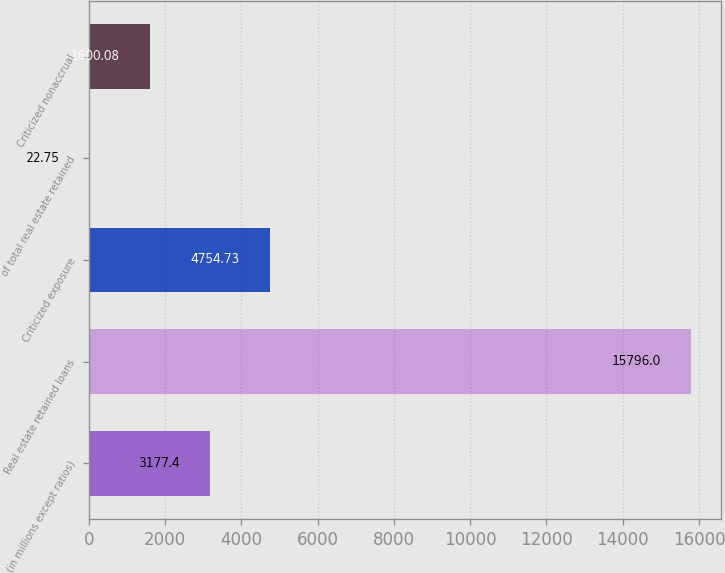<chart> <loc_0><loc_0><loc_500><loc_500><bar_chart><fcel>(in millions except ratios)<fcel>Real estate retained loans<fcel>Criticized exposure<fcel>of total real estate retained<fcel>Criticized nonaccrual<nl><fcel>3177.4<fcel>15796<fcel>4754.73<fcel>22.75<fcel>1600.08<nl></chart> 